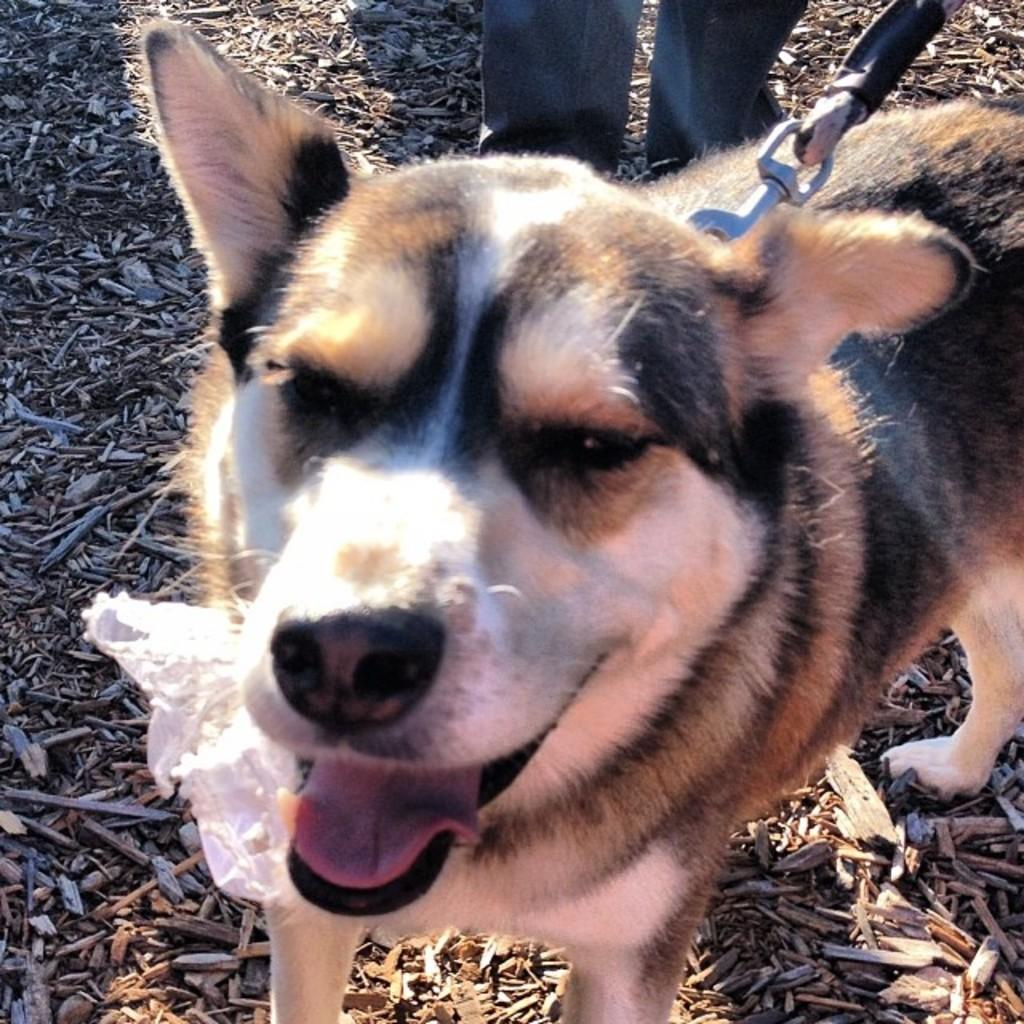What type of animal can be seen in the image? There is a dog in the image. What type of surface is visible in the image? There is ground visible in the image. What is present on the ground in the image? There are objects on the ground. Can you describe any part of a person in the image? The legs of a person are visible in the image. What channel is the dog watching in the image? There is no television or channel present in the image; it features a dog on the ground. What level of excitement can be observed in the image? There is no indication of excitement in the image; it simply shows a dog on the ground. 